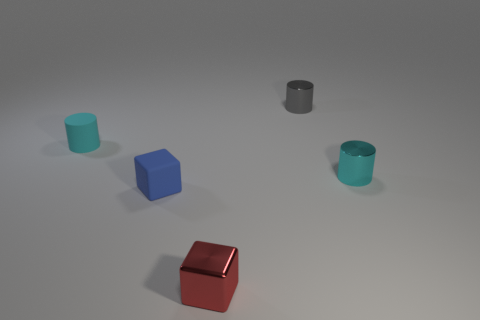Subtract all metallic cylinders. How many cylinders are left? 1 Subtract all cyan spheres. How many cyan cylinders are left? 2 Subtract all gray cylinders. How many cylinders are left? 2 Add 2 gray things. How many objects exist? 7 Subtract 1 cylinders. How many cylinders are left? 2 Subtract all cylinders. How many objects are left? 2 Add 3 small blue matte things. How many small blue matte things exist? 4 Subtract 0 gray balls. How many objects are left? 5 Subtract all purple cylinders. Subtract all red cubes. How many cylinders are left? 3 Subtract all red metallic objects. Subtract all tiny cyan shiny cylinders. How many objects are left? 3 